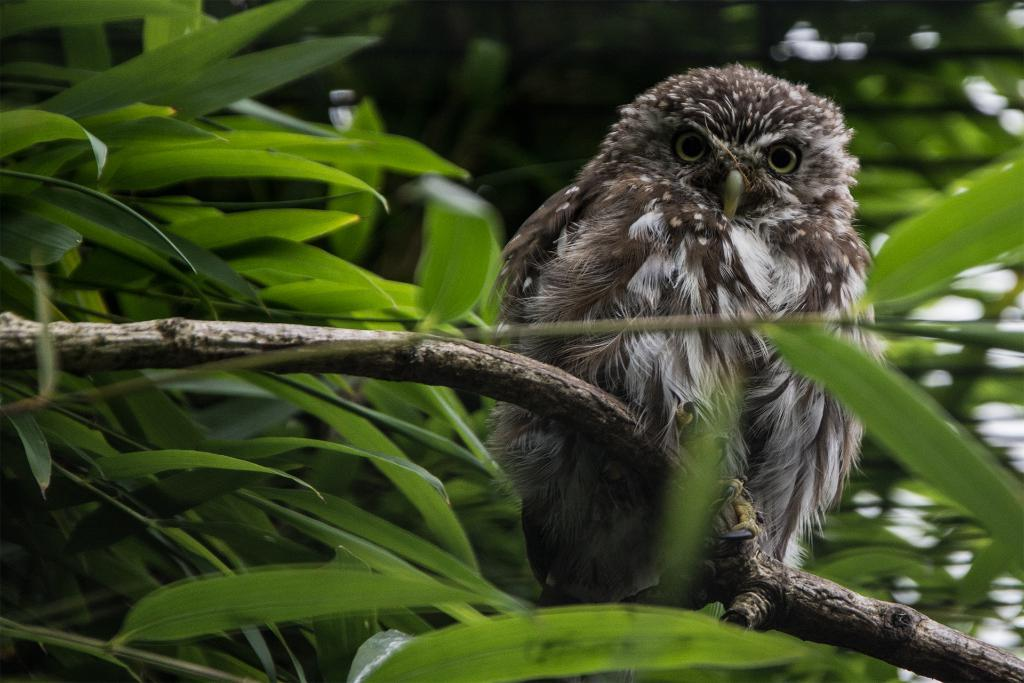What type of animal is in the image? There is an owl in the image. Where is the owl located in the image? The owl is on a branch of a tree. What part of the image does the owl occupy? The owl is in the foreground of the image. What channel is the owl watching in the image? There is no television or channel present in the image; it features an owl on a tree branch. 